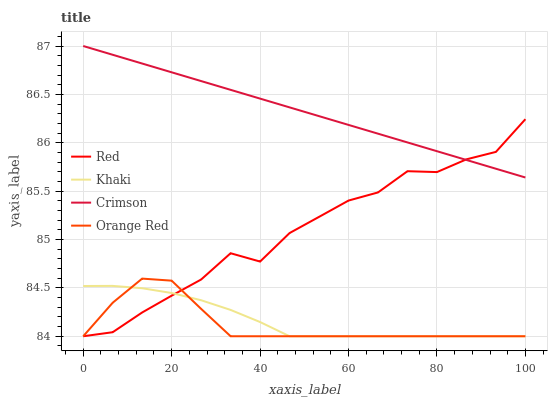Does Orange Red have the minimum area under the curve?
Answer yes or no. Yes. Does Crimson have the maximum area under the curve?
Answer yes or no. Yes. Does Khaki have the minimum area under the curve?
Answer yes or no. No. Does Khaki have the maximum area under the curve?
Answer yes or no. No. Is Crimson the smoothest?
Answer yes or no. Yes. Is Red the roughest?
Answer yes or no. Yes. Is Khaki the smoothest?
Answer yes or no. No. Is Khaki the roughest?
Answer yes or no. No. Does Khaki have the lowest value?
Answer yes or no. Yes. Does Crimson have the highest value?
Answer yes or no. Yes. Does Orange Red have the highest value?
Answer yes or no. No. Is Orange Red less than Crimson?
Answer yes or no. Yes. Is Crimson greater than Khaki?
Answer yes or no. Yes. Does Red intersect Crimson?
Answer yes or no. Yes. Is Red less than Crimson?
Answer yes or no. No. Is Red greater than Crimson?
Answer yes or no. No. Does Orange Red intersect Crimson?
Answer yes or no. No. 